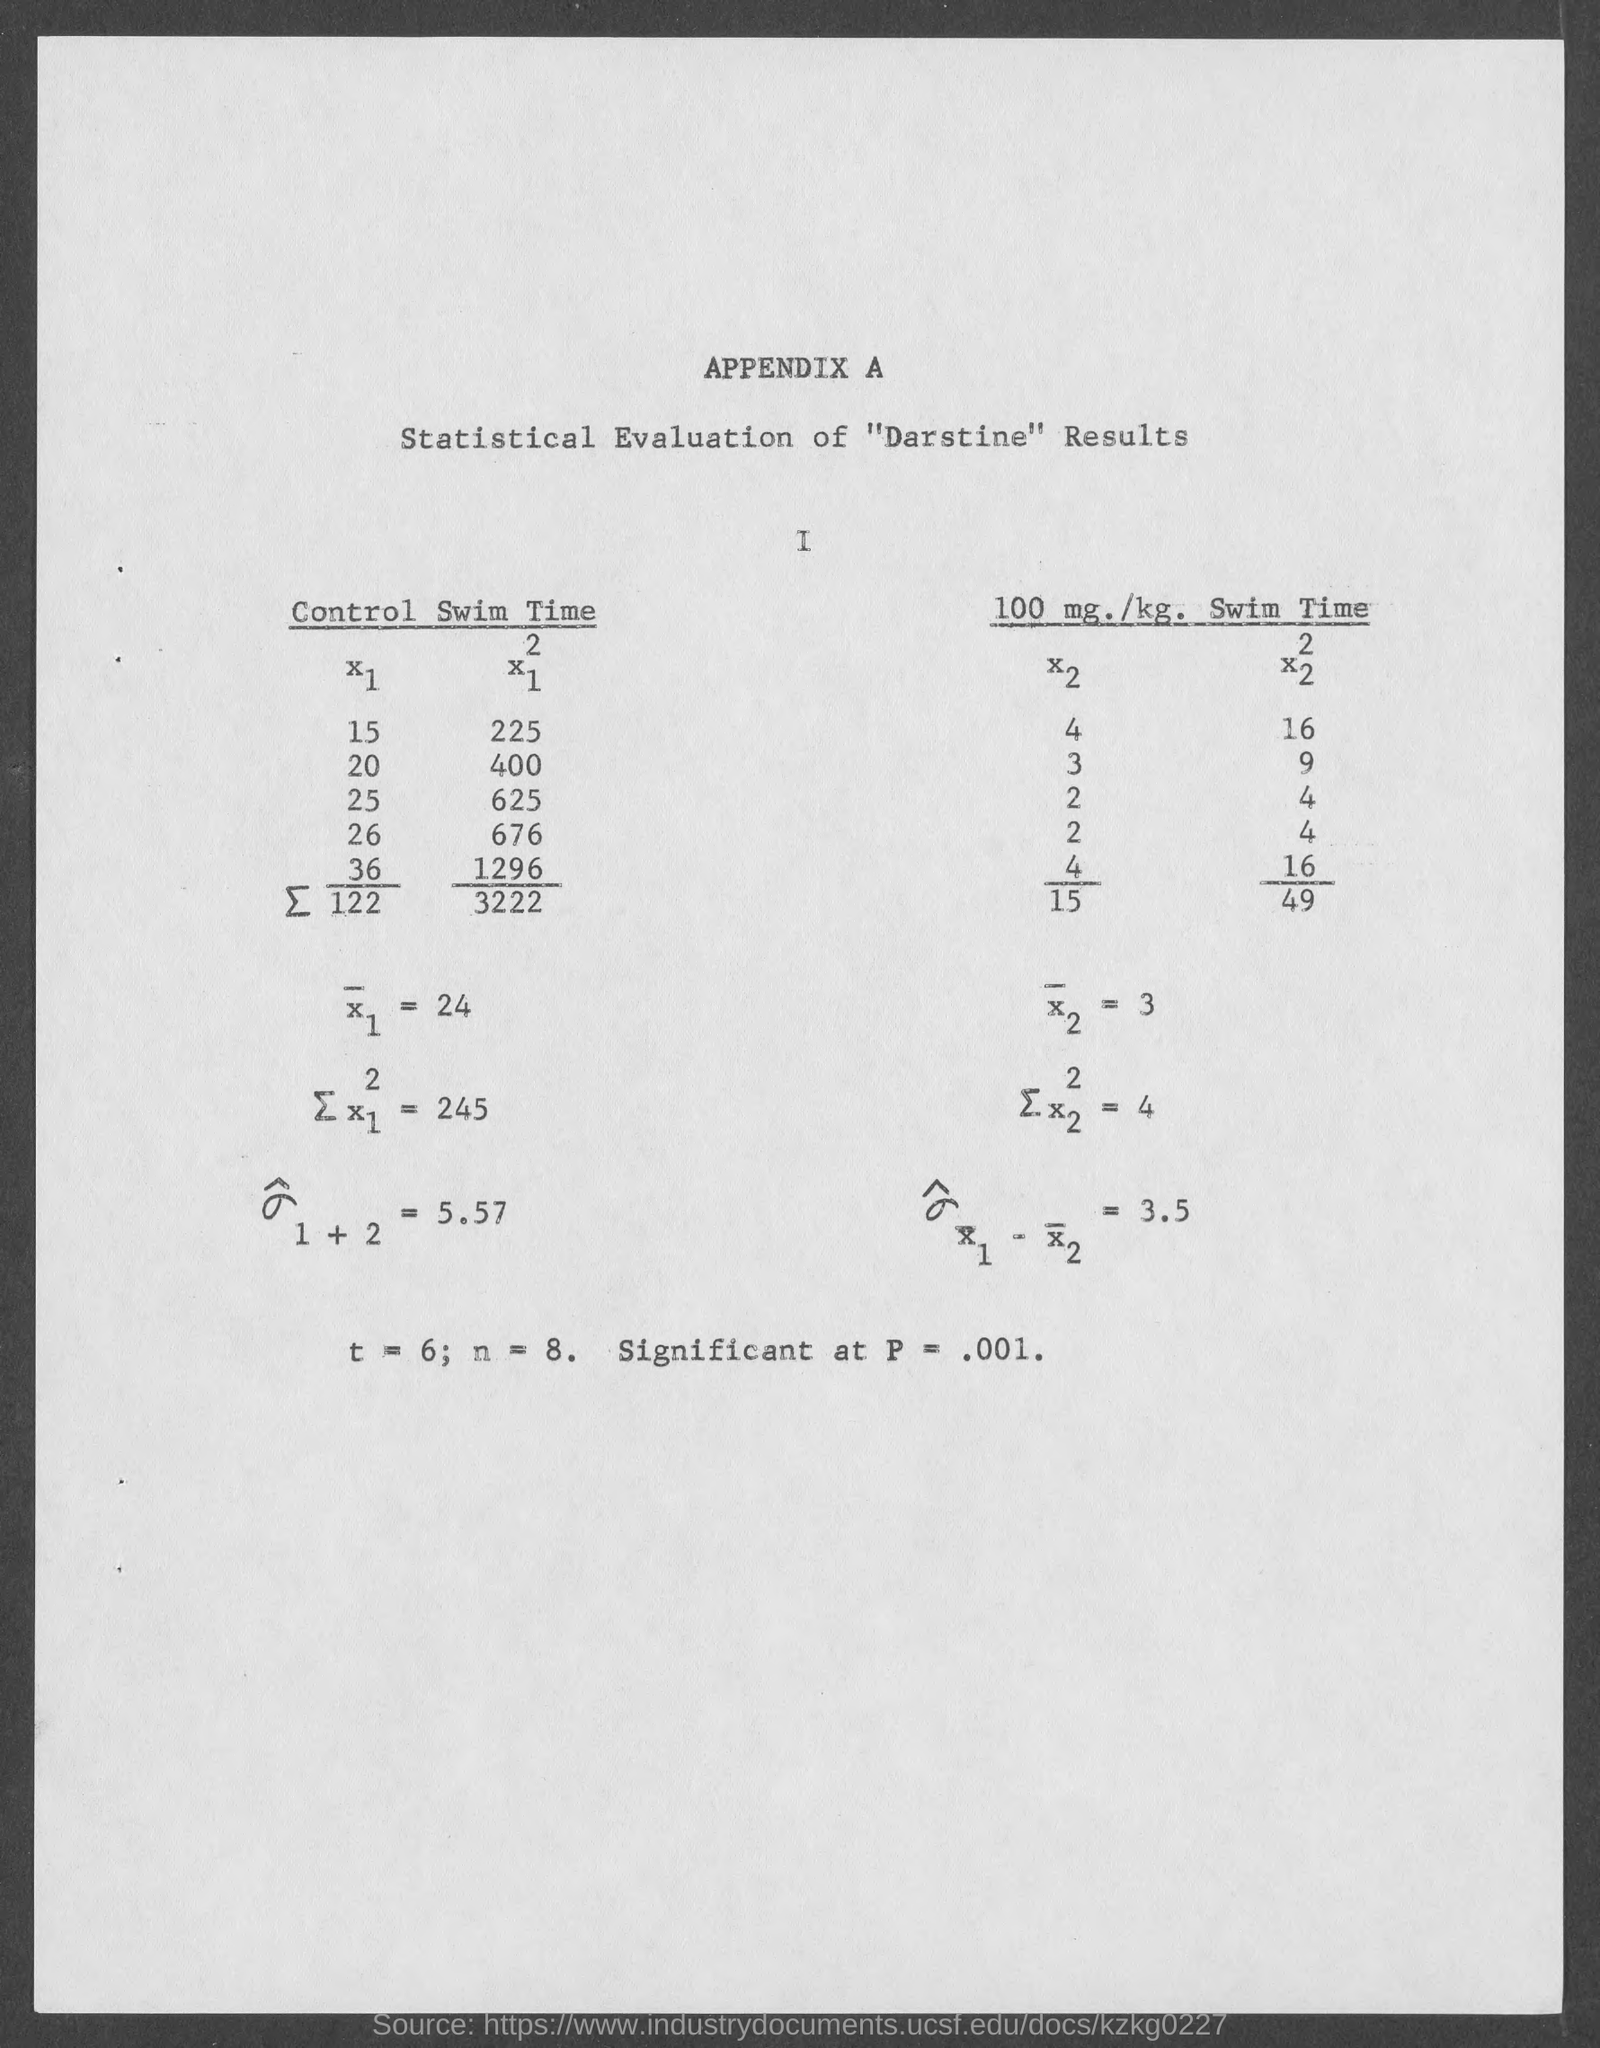What is t= ?
Make the answer very short. 6;. What is n =?
Ensure brevity in your answer.  8. What is significant at p =?
Make the answer very short. .001. 